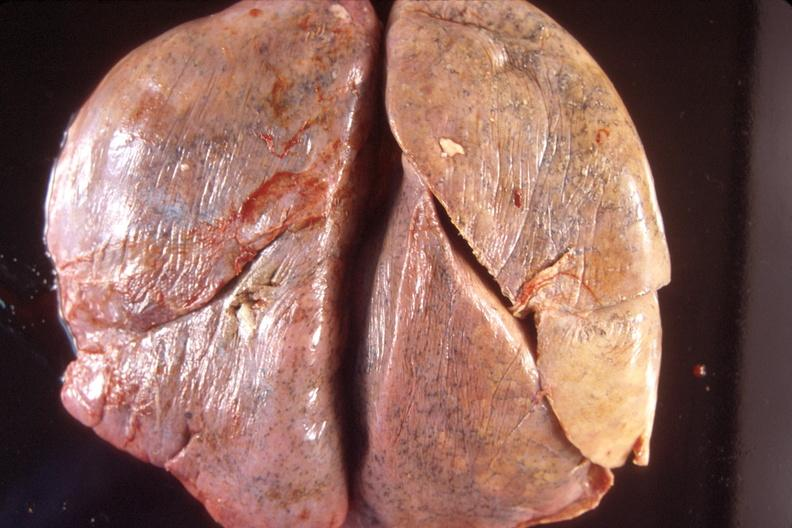what does this image show?
Answer the question using a single word or phrase. Normal lung 